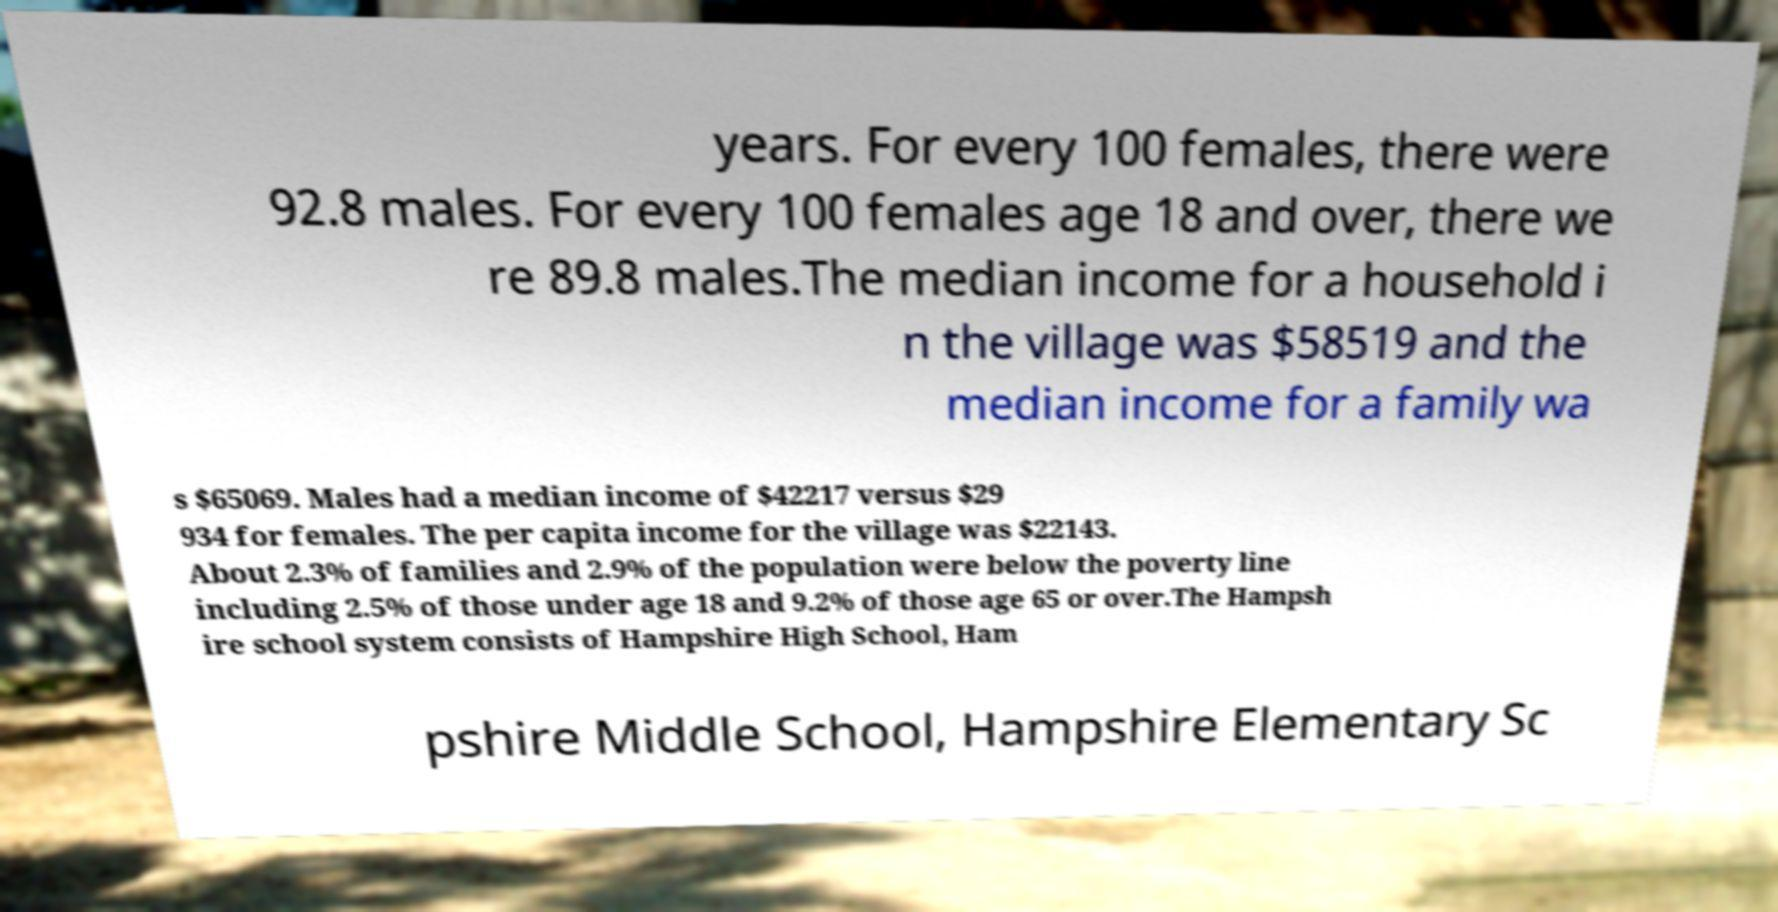Can you accurately transcribe the text from the provided image for me? years. For every 100 females, there were 92.8 males. For every 100 females age 18 and over, there we re 89.8 males.The median income for a household i n the village was $58519 and the median income for a family wa s $65069. Males had a median income of $42217 versus $29 934 for females. The per capita income for the village was $22143. About 2.3% of families and 2.9% of the population were below the poverty line including 2.5% of those under age 18 and 9.2% of those age 65 or over.The Hampsh ire school system consists of Hampshire High School, Ham pshire Middle School, Hampshire Elementary Sc 